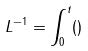Convert formula to latex. <formula><loc_0><loc_0><loc_500><loc_500>L ^ { - 1 } = \int _ { 0 } ^ { t } ( )</formula> 